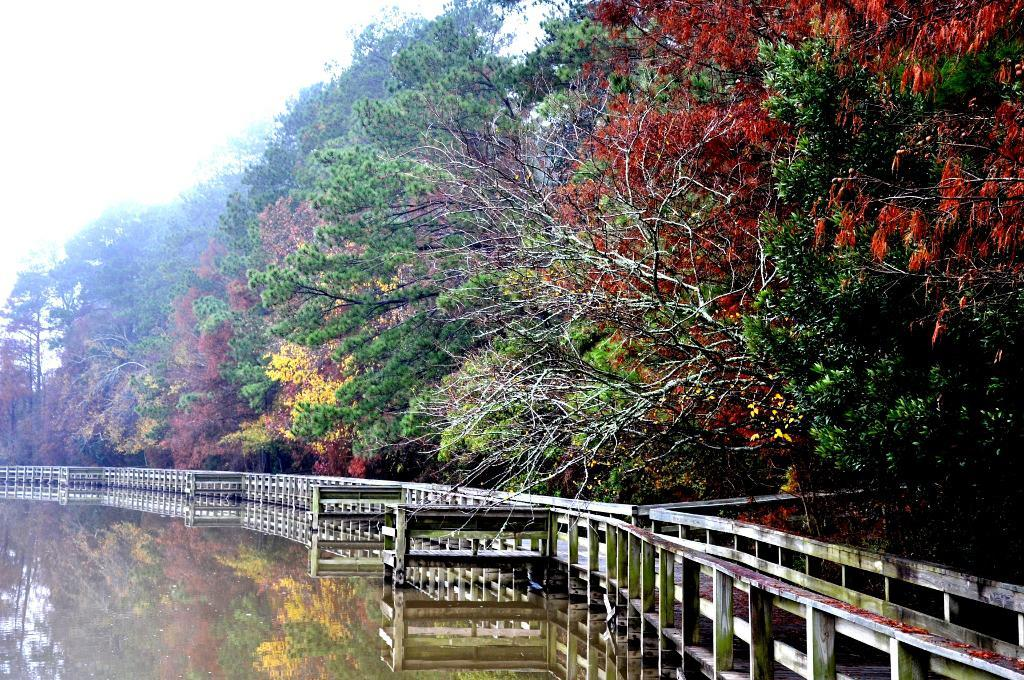What is the primary element in the image? There is water in the image. What structure is built on the water? There is a dock on the water. What feature is present on the dock? There is a railing on the dock. What can be seen in the background of the image? There are trees in the background of the image. What is visible at the top of the image? The sky is visible at the top of the image. What type of cheese is being used to build the dock in the image? There is no cheese present in the image, and the dock is not being built with cheese. What is the tendency of the spade in the image? There is no spade present in the image, so it is not possible to determine its tendency. 